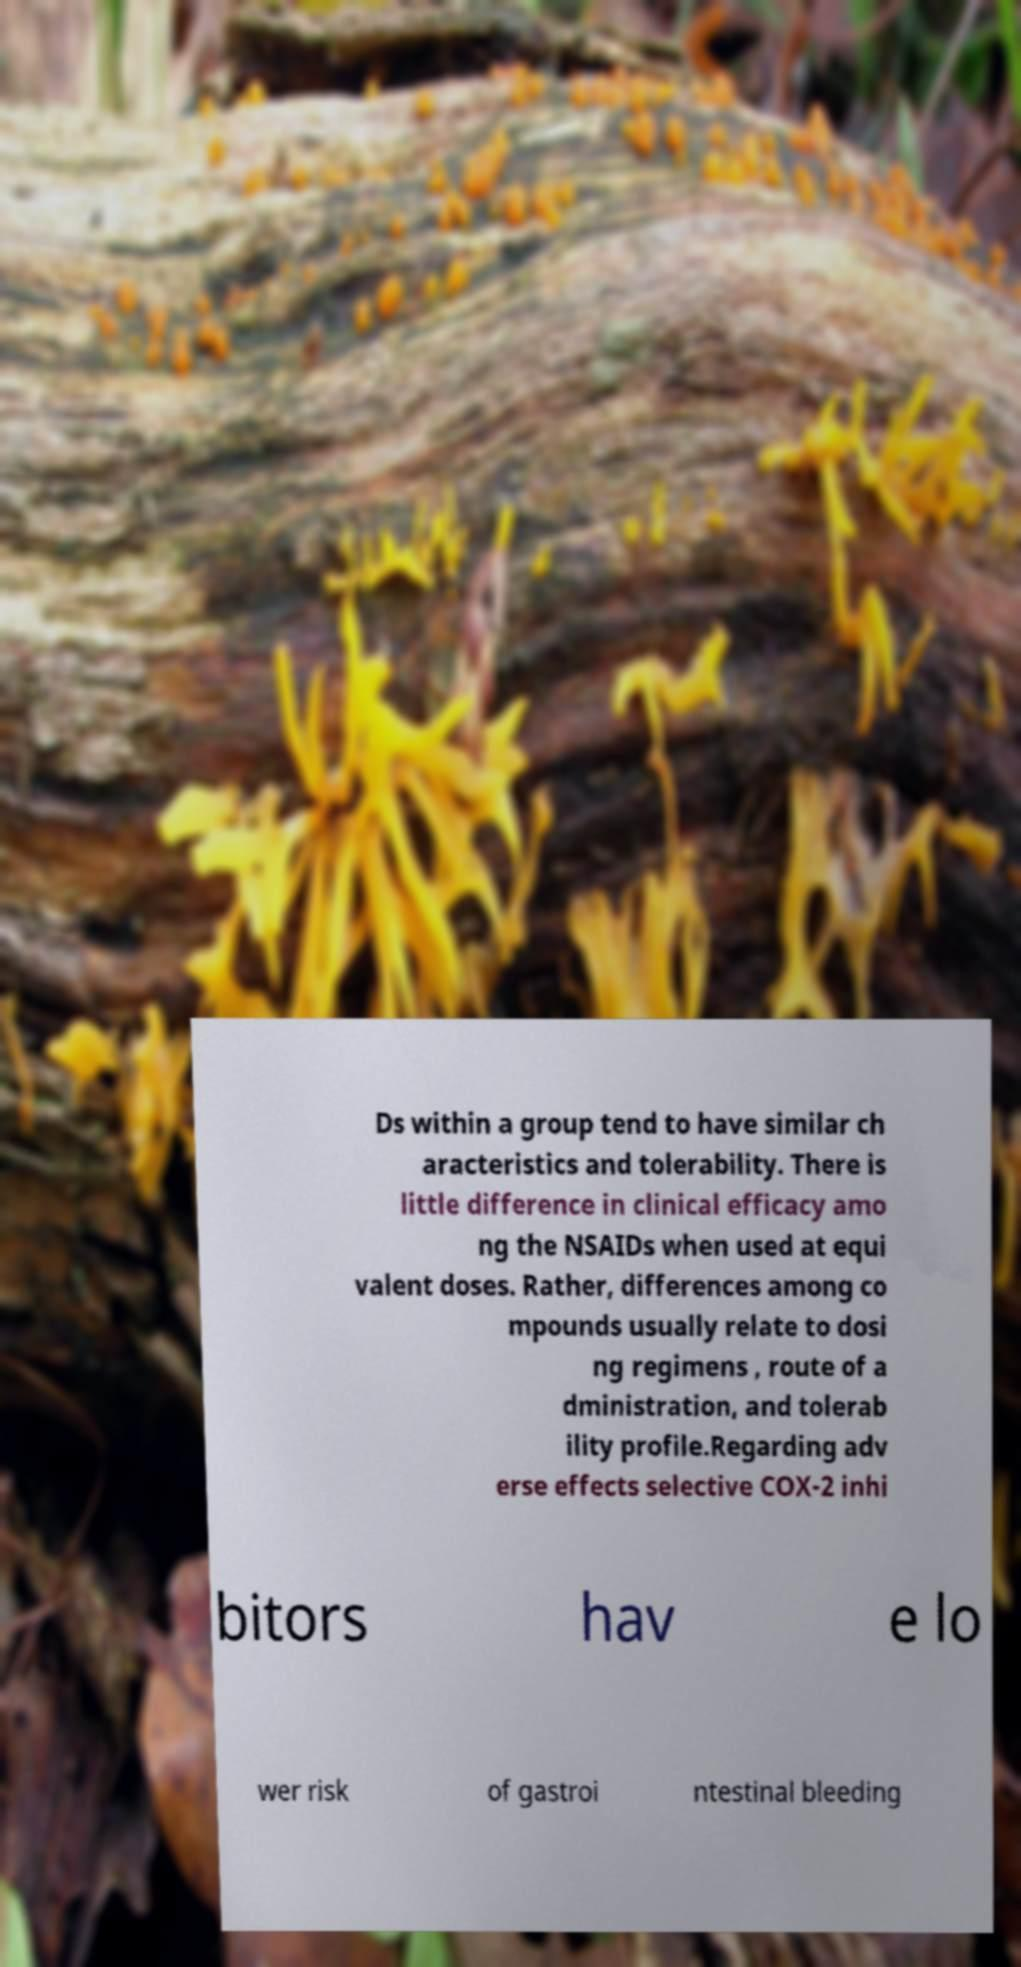I need the written content from this picture converted into text. Can you do that? Ds within a group tend to have similar ch aracteristics and tolerability. There is little difference in clinical efficacy amo ng the NSAIDs when used at equi valent doses. Rather, differences among co mpounds usually relate to dosi ng regimens , route of a dministration, and tolerab ility profile.Regarding adv erse effects selective COX-2 inhi bitors hav e lo wer risk of gastroi ntestinal bleeding 